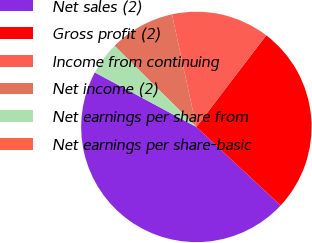Convert chart to OTSL. <chart><loc_0><loc_0><loc_500><loc_500><pie_chart><fcel>Net sales (2)<fcel>Gross profit (2)<fcel>Income from continuing<fcel>Net income (2)<fcel>Net earnings per share from<fcel>Net earnings per share-basic<nl><fcel>45.89%<fcel>26.57%<fcel>13.77%<fcel>9.18%<fcel>4.59%<fcel>0.0%<nl></chart> 